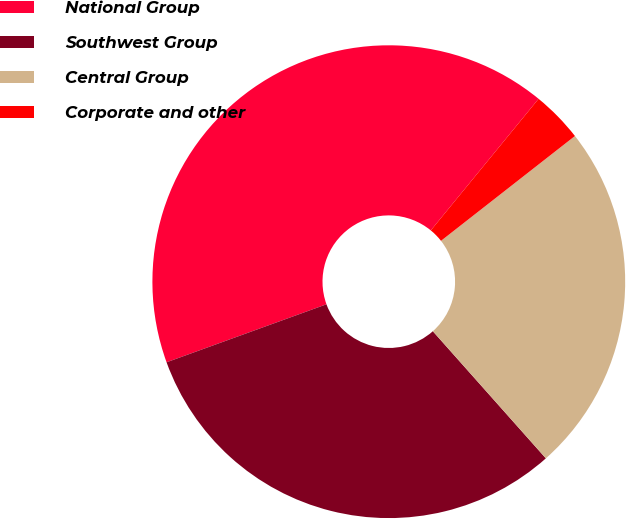Convert chart to OTSL. <chart><loc_0><loc_0><loc_500><loc_500><pie_chart><fcel>National Group<fcel>Southwest Group<fcel>Central Group<fcel>Corporate and other<nl><fcel>41.46%<fcel>31.03%<fcel>24.0%<fcel>3.51%<nl></chart> 